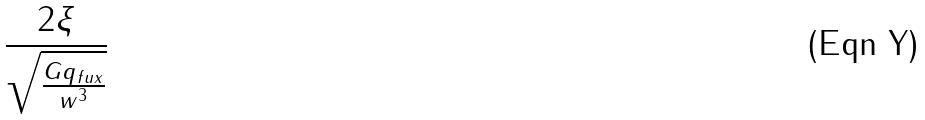Convert formula to latex. <formula><loc_0><loc_0><loc_500><loc_500>\frac { 2 \xi } { \sqrt { \frac { G q _ { f u x } } { w ^ { 3 } } } }</formula> 